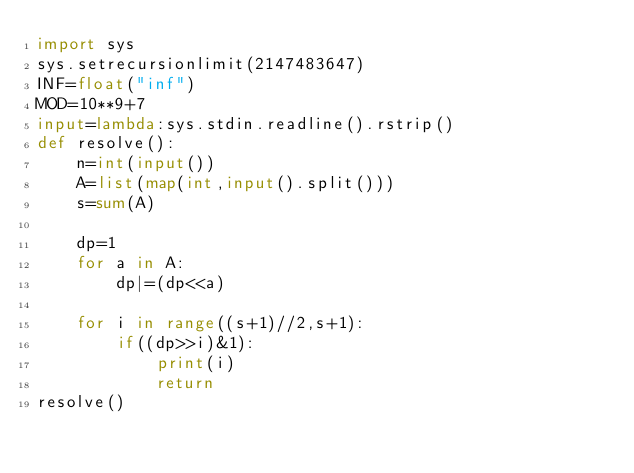<code> <loc_0><loc_0><loc_500><loc_500><_Python_>import sys
sys.setrecursionlimit(2147483647)
INF=float("inf")
MOD=10**9+7
input=lambda:sys.stdin.readline().rstrip()
def resolve():
    n=int(input())
    A=list(map(int,input().split()))
    s=sum(A)

    dp=1
    for a in A:
        dp|=(dp<<a)

    for i in range((s+1)//2,s+1):
        if((dp>>i)&1):
            print(i)
            return
resolve()</code> 